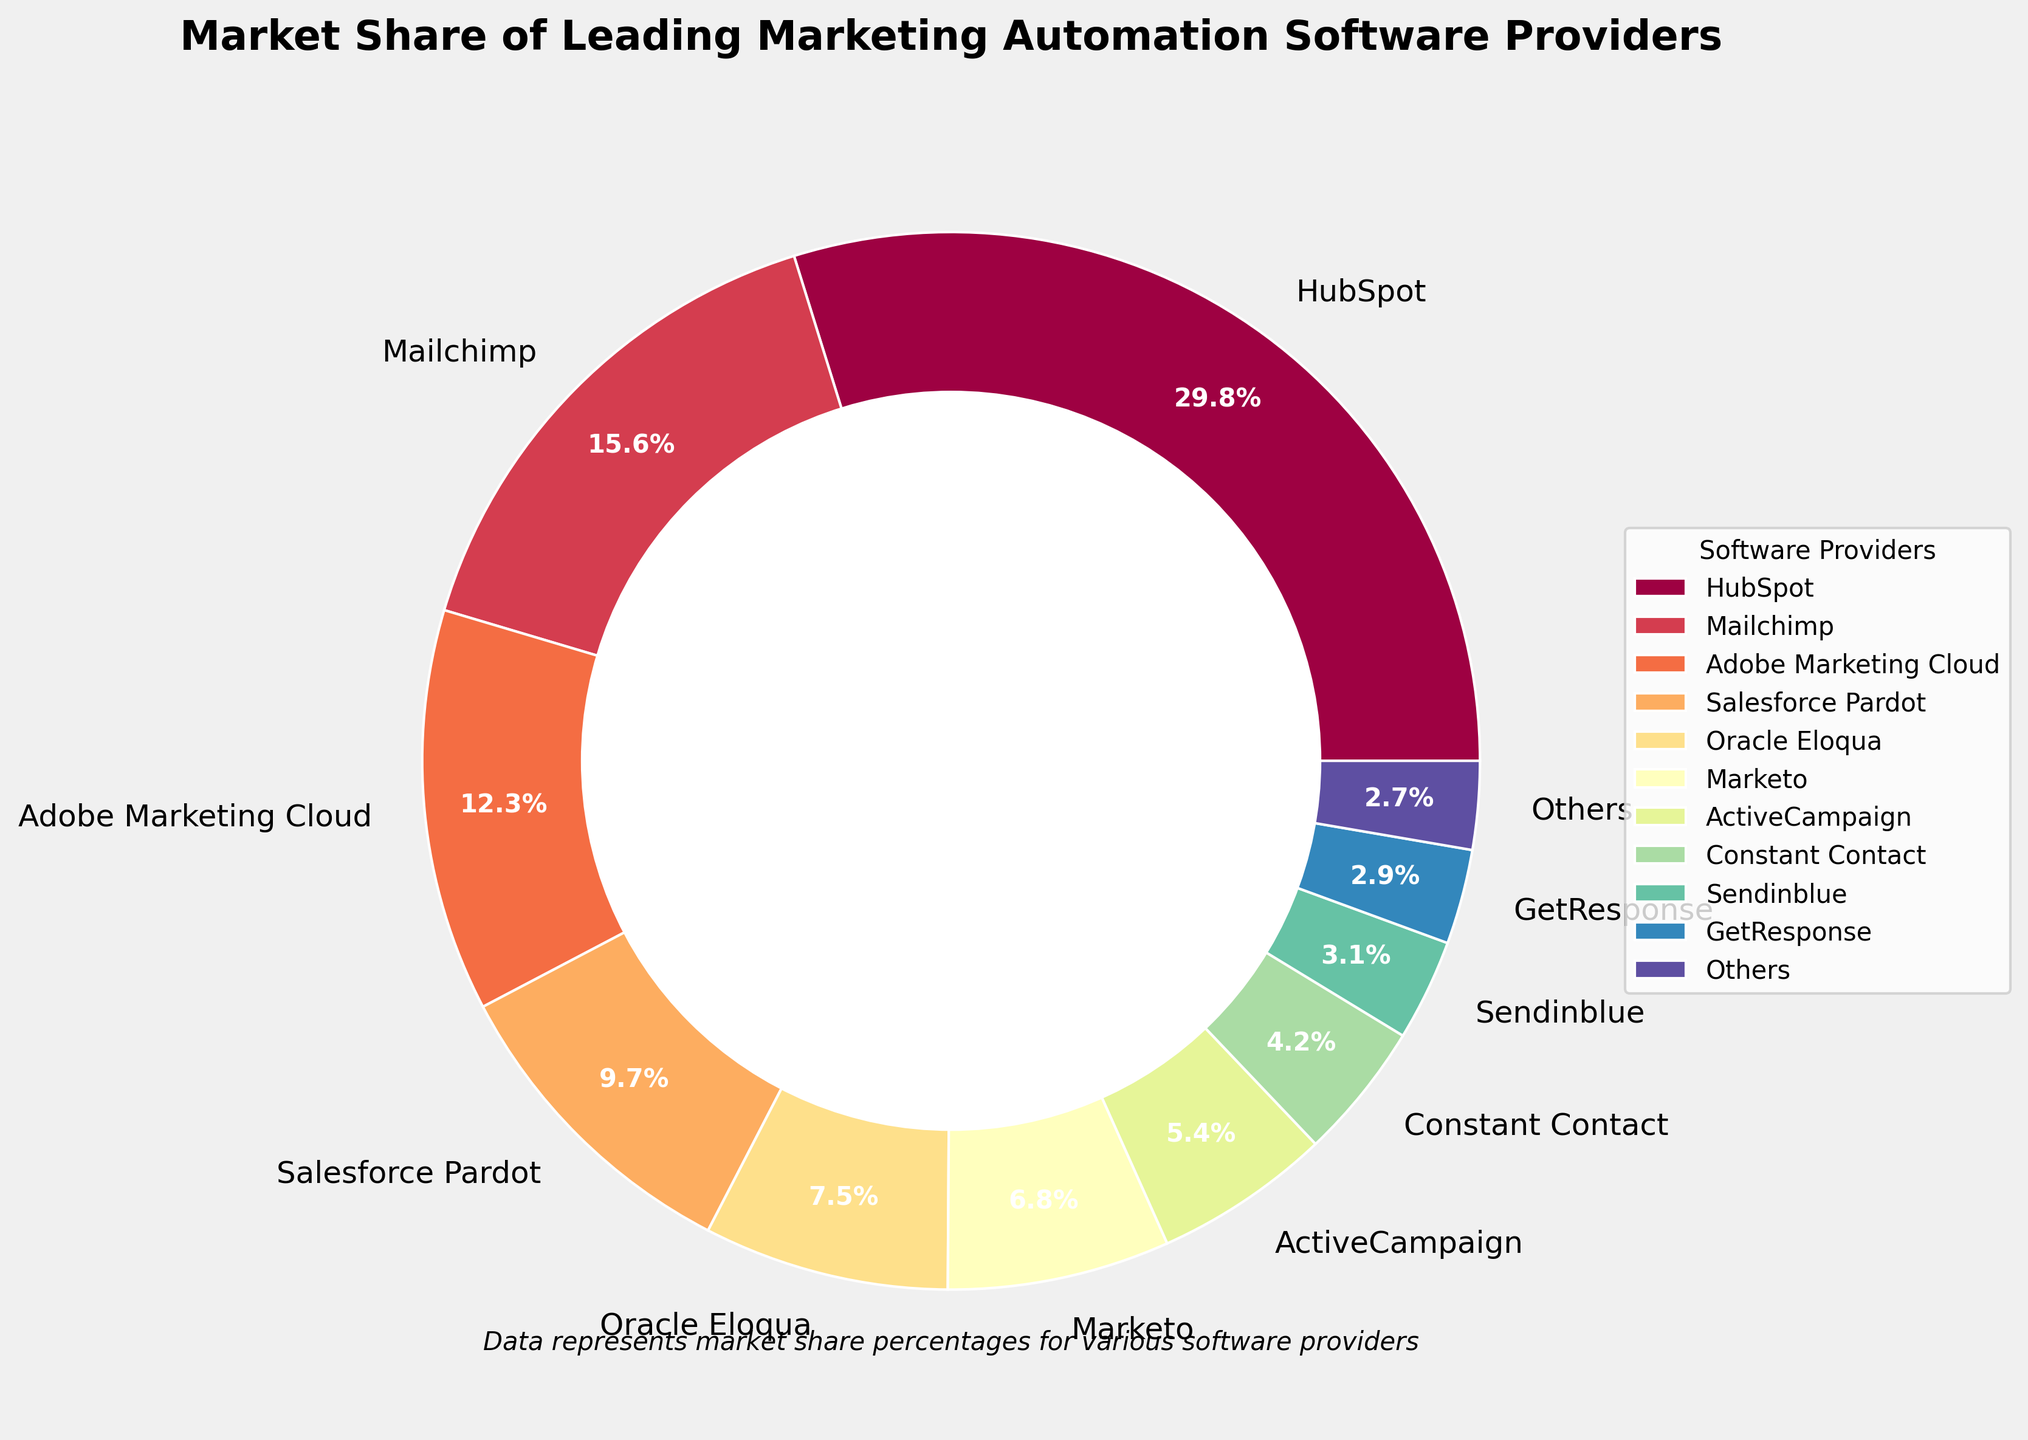What percentage of the market share does the top software provider hold? Find HubSpot in the chart and note its percentage share. HubSpot holds 29.8% of the market share.
Answer: 29.8% How many software providers have a market share greater than 10%? Identify the software providers with shares greater than 10%. There are three: HubSpot (29.8%), Mailchimp (15.6%), and Adobe Marketing Cloud (12.3%).
Answer: 3 What is the combined market share of Salesforce Pardot and Oracle Eloqua? Add their shares together: 9.7% (Salesforce Pardot) + 7.5% (Oracle Eloqua) = 17.2%.
Answer: 17.2% Which software provider has the smallest market share, and what is its percentage? Identify the provider with the smallest share in the chart. GetResponse has the smallest market share at 2.7%.
Answer: GetResponse, 2.7% What is the average market share of the software providers listed (excluding 'Others')? Add the percentages of the listed providers and divide by the number of providers: 
(29.8 + 15.6 + 12.3 + 9.7 + 7.5 + 6.8 + 5.4 + 4.2 + 3.1 + 2.9) / 10 = 9.73%.
Answer: 9.73% Which software providers have a market share less than 5%? Identify providers with shares less than 5%. These are Constant Contact (4.2%), Sendinblue (3.1%), and GetResponse (2.9%).
Answer: Constant Contact, Sendinblue, GetResponse Compare the market share between ActiveCampaign and Constant Contact. Which one has a higher share and by how much? ActiveCampaign has a 5.4% share and Constant Contact has 4.2%. The difference is 5.4% - 4.2% = 1.2%.
Answer: ActiveCampaign, 1.2% What proportion of the total market does "Others" contribute? The "Others" category contributes 2.7% as indicated in the chart.
Answer: 2.7% If the market share of Adobe Marketing Cloud increases by 5%, what would its new market share be? Current share of Adobe Marketing Cloud is 12.3%. Adding 5% results in 12.3% + 5% = 17.3%.
Answer: 17.3% 